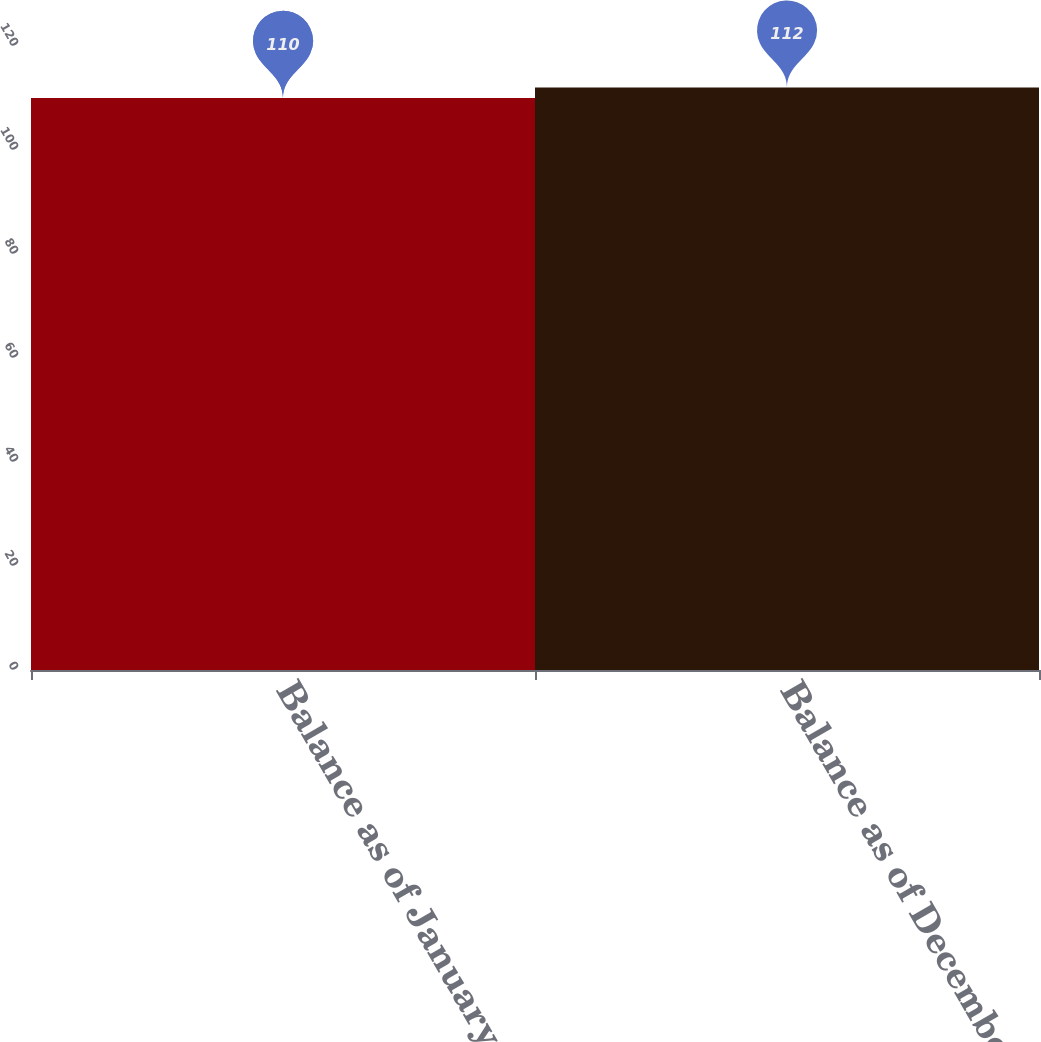Convert chart. <chart><loc_0><loc_0><loc_500><loc_500><bar_chart><fcel>Balance as of January 1<fcel>Balance as of December 31<nl><fcel>110<fcel>112<nl></chart> 